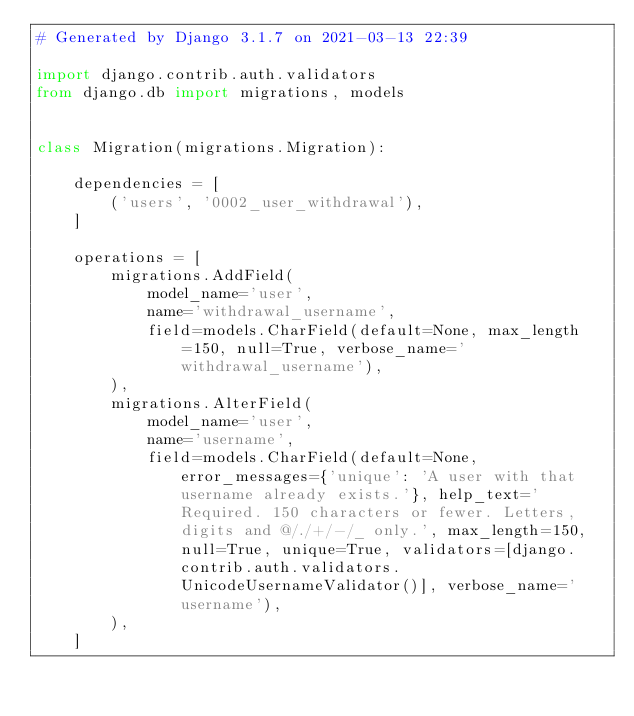Convert code to text. <code><loc_0><loc_0><loc_500><loc_500><_Python_># Generated by Django 3.1.7 on 2021-03-13 22:39

import django.contrib.auth.validators
from django.db import migrations, models


class Migration(migrations.Migration):

    dependencies = [
        ('users', '0002_user_withdrawal'),
    ]

    operations = [
        migrations.AddField(
            model_name='user',
            name='withdrawal_username',
            field=models.CharField(default=None, max_length=150, null=True, verbose_name='withdrawal_username'),
        ),
        migrations.AlterField(
            model_name='user',
            name='username',
            field=models.CharField(default=None, error_messages={'unique': 'A user with that username already exists.'}, help_text='Required. 150 characters or fewer. Letters, digits and @/./+/-/_ only.', max_length=150, null=True, unique=True, validators=[django.contrib.auth.validators.UnicodeUsernameValidator()], verbose_name='username'),
        ),
    ]
</code> 